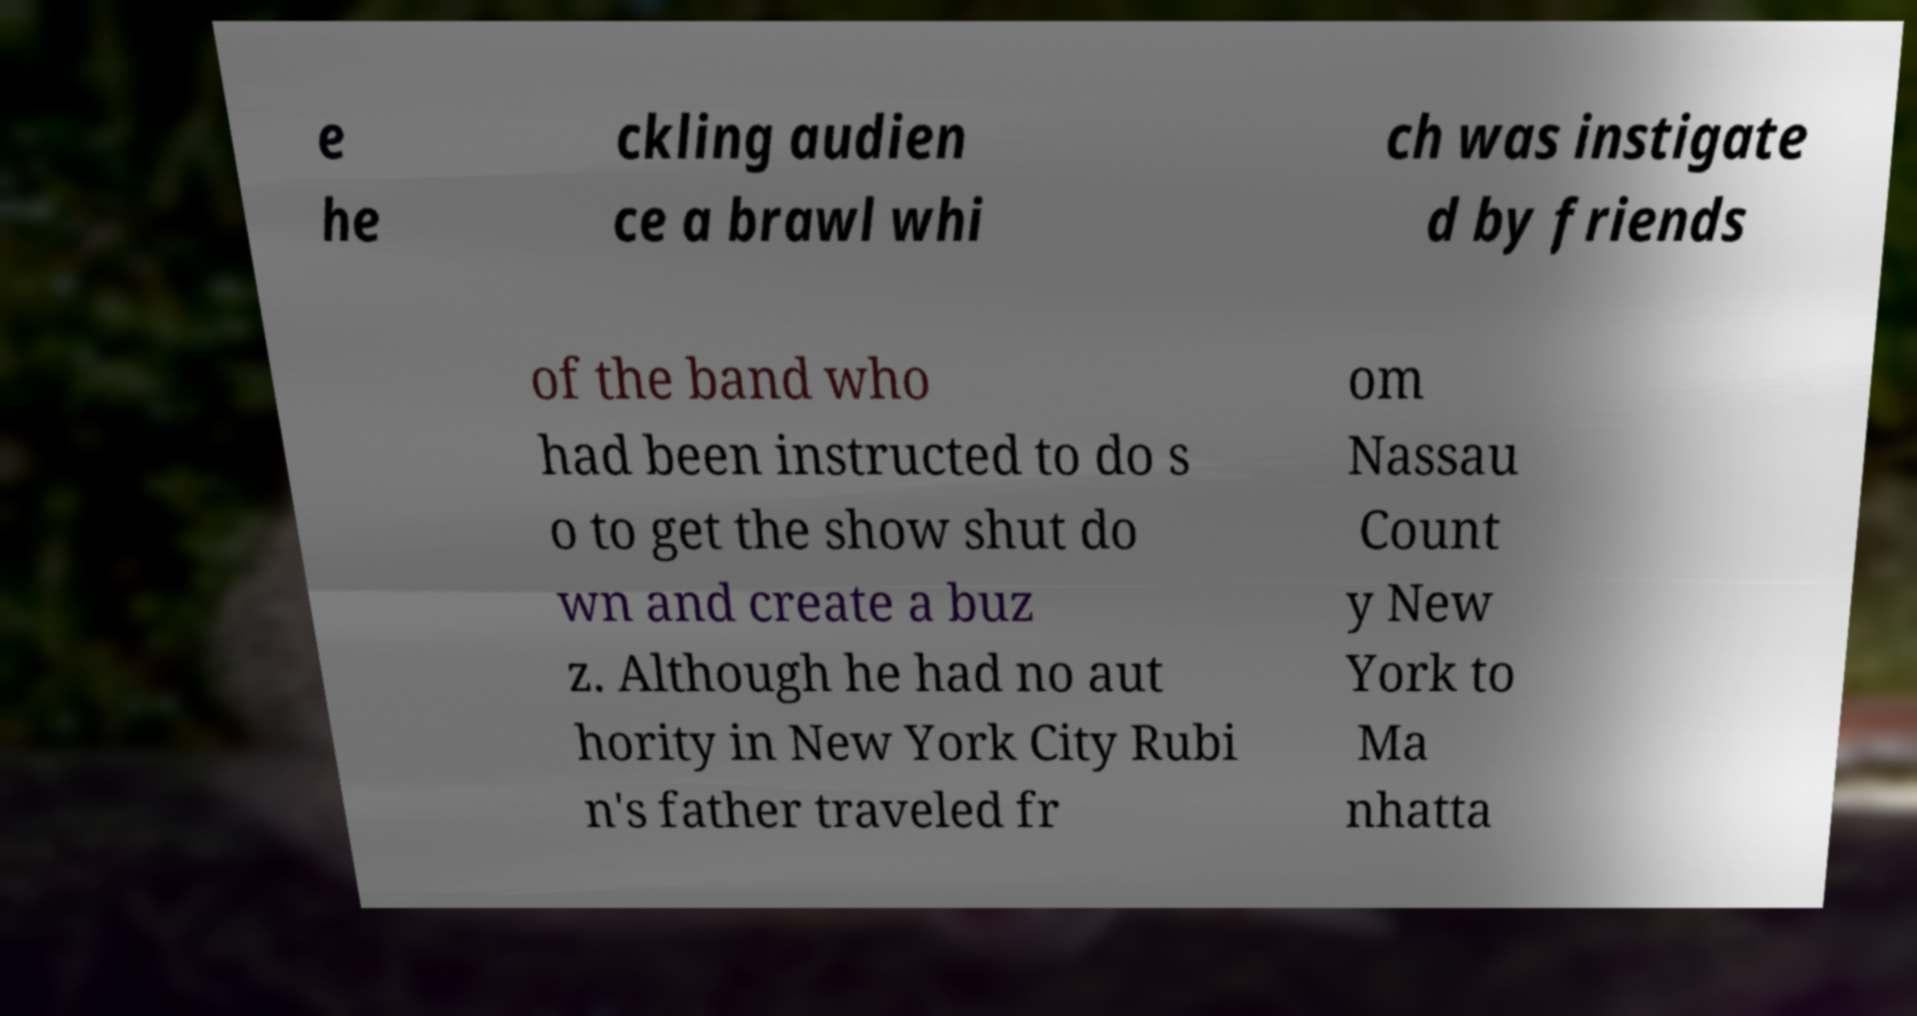Can you accurately transcribe the text from the provided image for me? e he ckling audien ce a brawl whi ch was instigate d by friends of the band who had been instructed to do s o to get the show shut do wn and create a buz z. Although he had no aut hority in New York City Rubi n's father traveled fr om Nassau Count y New York to Ma nhatta 